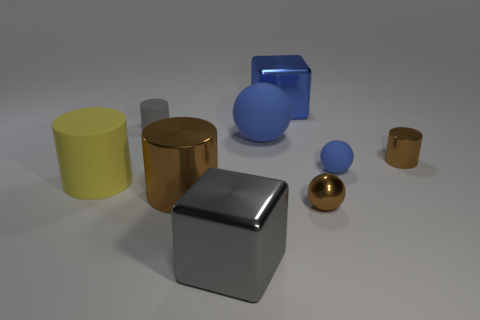Does the large metallic cylinder have the same color as the small metal ball?
Keep it short and to the point. Yes. What is the shape of the rubber object that is the same color as the tiny rubber sphere?
Provide a short and direct response. Sphere. How many blue matte objects have the same shape as the big blue shiny thing?
Your response must be concise. 0. The other blue sphere that is the same material as the big blue sphere is what size?
Keep it short and to the point. Small. Is the size of the gray metal block the same as the blue metal object?
Your answer should be compact. Yes. Is there a brown rubber sphere?
Give a very brief answer. No. What size is the block that is the same color as the tiny rubber ball?
Provide a short and direct response. Large. There is a cube that is left of the block behind the small matte object on the left side of the small metallic ball; what size is it?
Offer a very short reply. Large. What number of large balls are the same material as the big yellow thing?
Ensure brevity in your answer.  1. What number of other brown shiny spheres are the same size as the brown shiny sphere?
Keep it short and to the point. 0. 